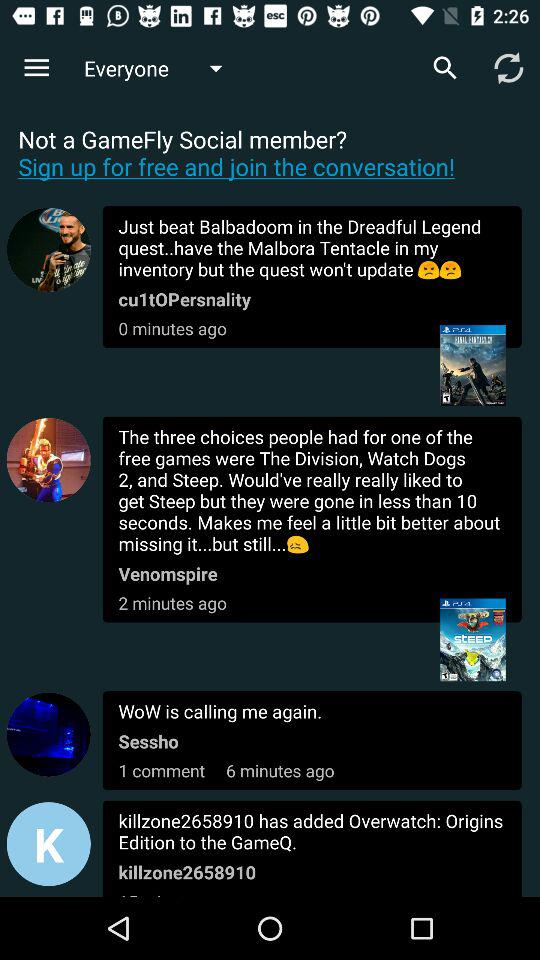When did Sessho message? Sessho messaged 6 minutes ago. 